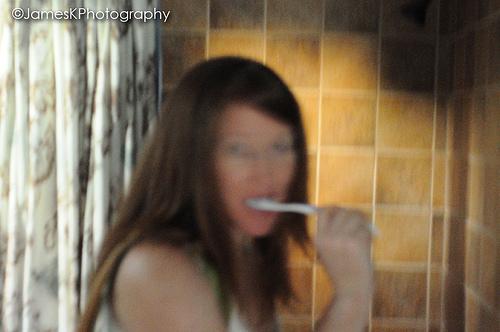What is the girl doing?
Answer briefly. Brushing teeth. What is in her hand?
Be succinct. Toothbrush. Is she in a bathroom?
Be succinct. Yes. 